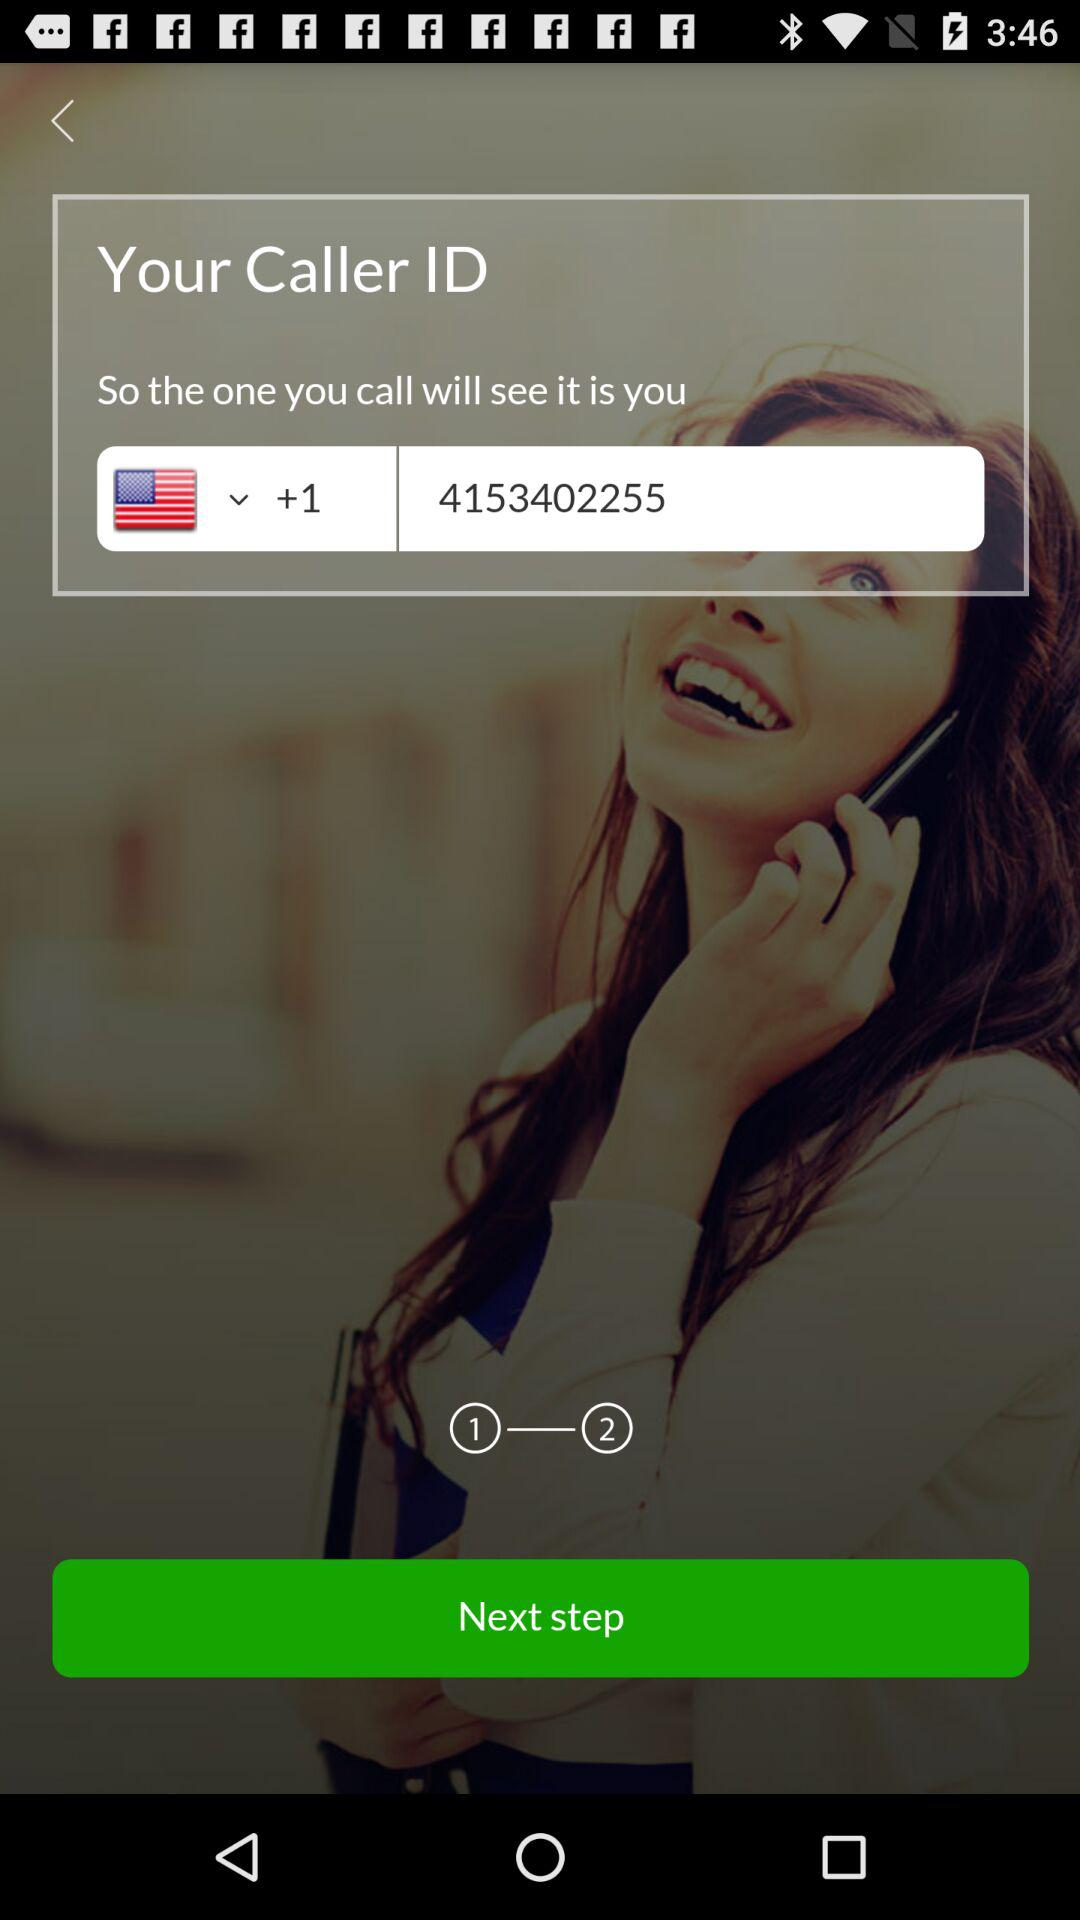How many numbers are there in the phone number?
Answer the question using a single word or phrase. 10 